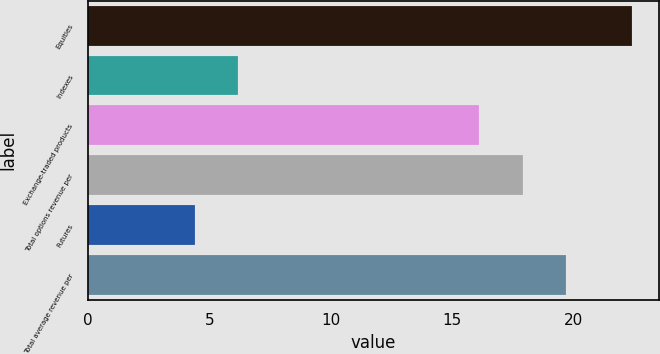Convert chart. <chart><loc_0><loc_0><loc_500><loc_500><bar_chart><fcel>Equities<fcel>Indexes<fcel>Exchange-traded products<fcel>Total options revenue per<fcel>Futures<fcel>Total average revenue per<nl><fcel>22.4<fcel>6.2<fcel>16.1<fcel>17.9<fcel>4.4<fcel>19.7<nl></chart> 